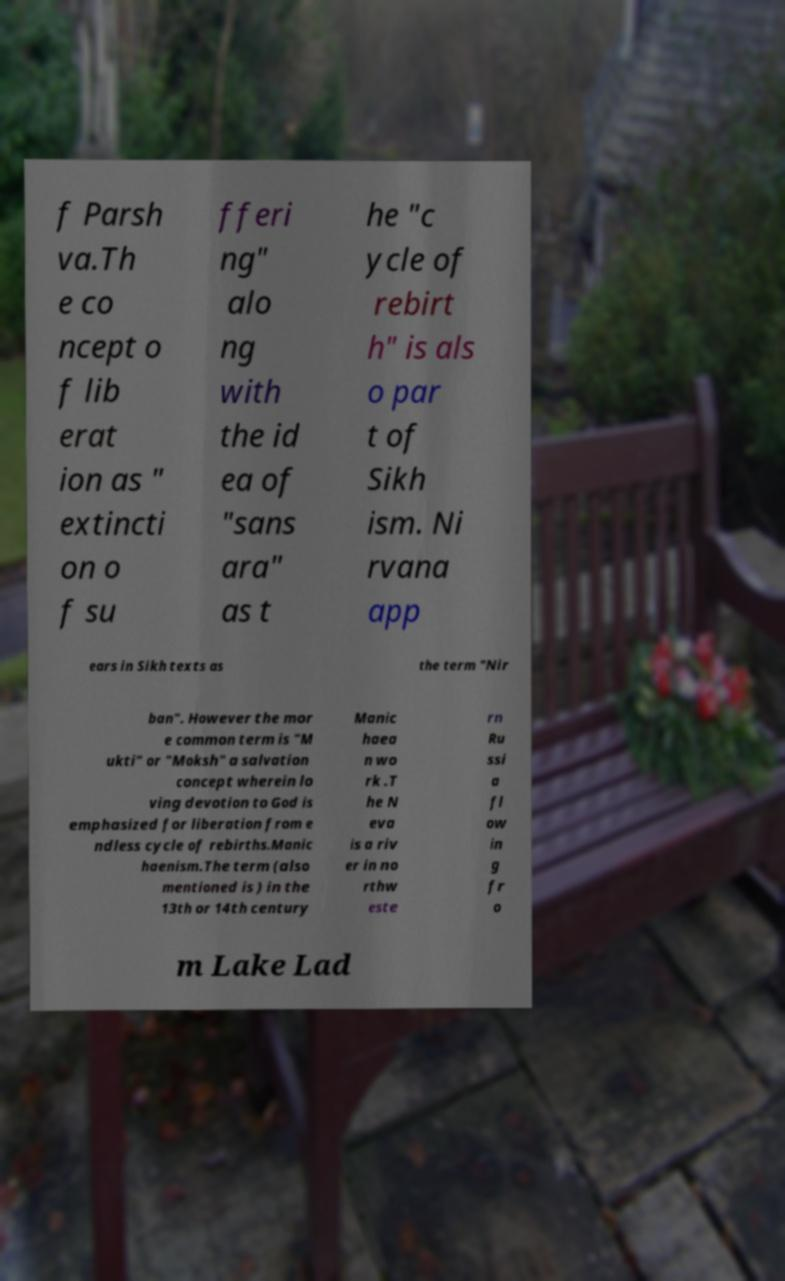Could you extract and type out the text from this image? f Parsh va.Th e co ncept o f lib erat ion as " extincti on o f su fferi ng" alo ng with the id ea of "sans ara" as t he "c ycle of rebirt h" is als o par t of Sikh ism. Ni rvana app ears in Sikh texts as the term "Nir ban". However the mor e common term is "M ukti" or "Moksh" a salvation concept wherein lo ving devotion to God is emphasized for liberation from e ndless cycle of rebirths.Manic haenism.The term (also mentioned is ) in the 13th or 14th century Manic haea n wo rk .T he N eva is a riv er in no rthw este rn Ru ssi a fl ow in g fr o m Lake Lad 